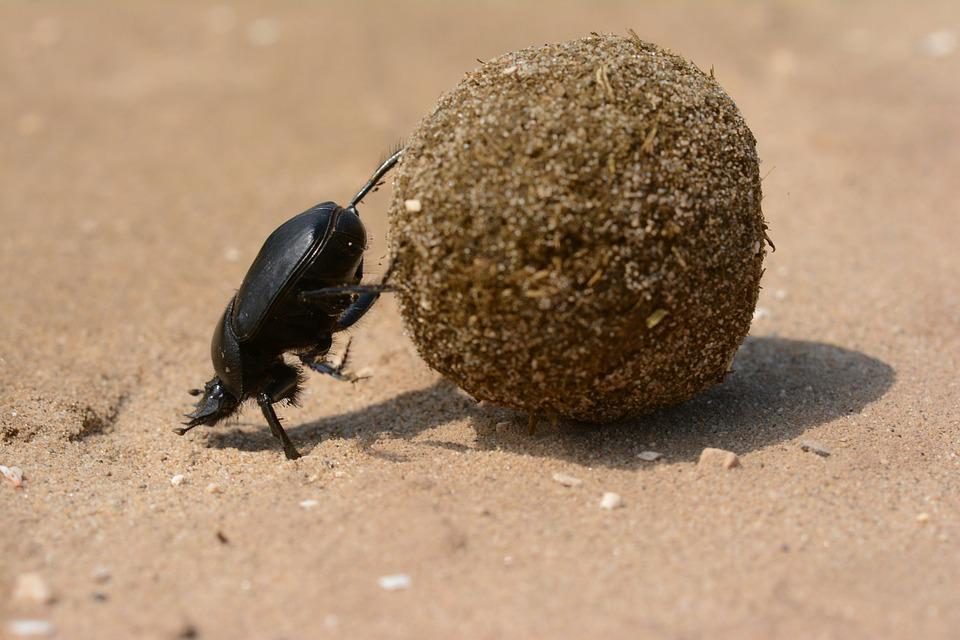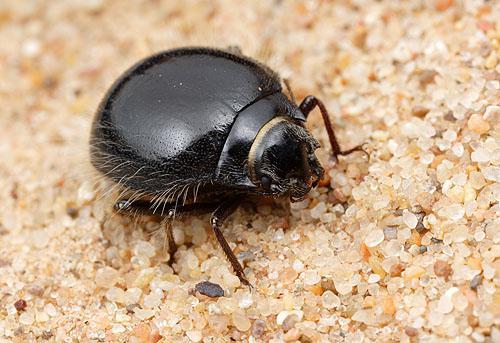The first image is the image on the left, the second image is the image on the right. Considering the images on both sides, is "Each image includes a beetle with a dungball that is bigger than the beetle." valid? Answer yes or no. No. The first image is the image on the left, the second image is the image on the right. Examine the images to the left and right. Is the description "There are two beetles near one clod of dirt in one of the images." accurate? Answer yes or no. No. 